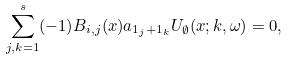<formula> <loc_0><loc_0><loc_500><loc_500>\sum _ { j , k = 1 } ^ { s } ( - 1 ) B _ { i , j } ( x ) a _ { 1 _ { j } + 1 _ { k } } U _ { \emptyset } ( x ; k , \omega ) = 0 ,</formula> 